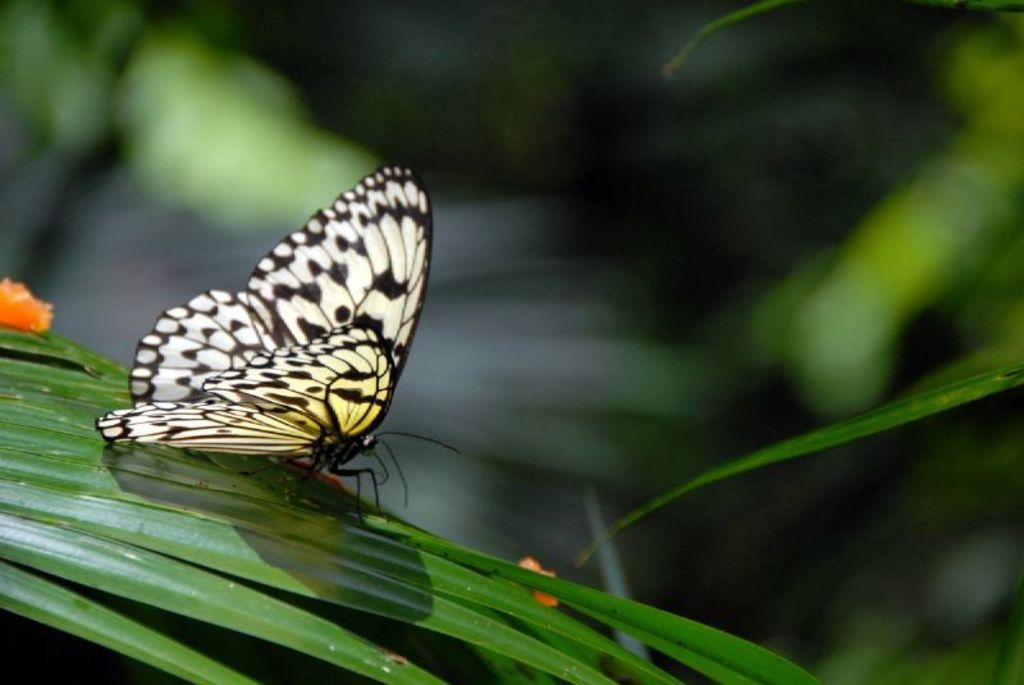What is the main subject of the image? There is a butterfly in the image. Can you describe the colors of the butterfly? The butterfly has white, black, and yellow colors. Where is the butterfly located in the image? The butterfly is on a green leaf. What other colors are present in the image? There are orange colored objects in the image. How would you describe the background of the image? The background of the image is blurry. Are there any dinosaurs playing chess in the image? No, there are no dinosaurs or chess games present in the image. The image features a butterfly on a green leaf with orange objects in the background. 